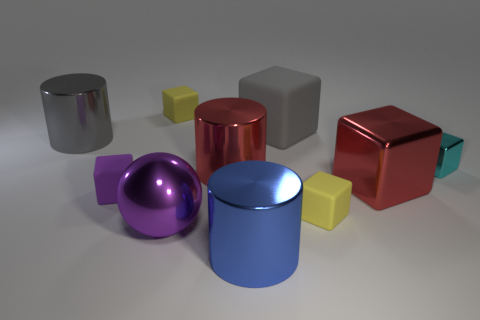Does the gray block have the same material as the purple block? While the gray block shares a matte appearance with the purple block, suggesting a similar material, it's hard to confirm without additional information. Specifics like texture and weight, which aren't discernible in a photo, play a critical role in material identification. 